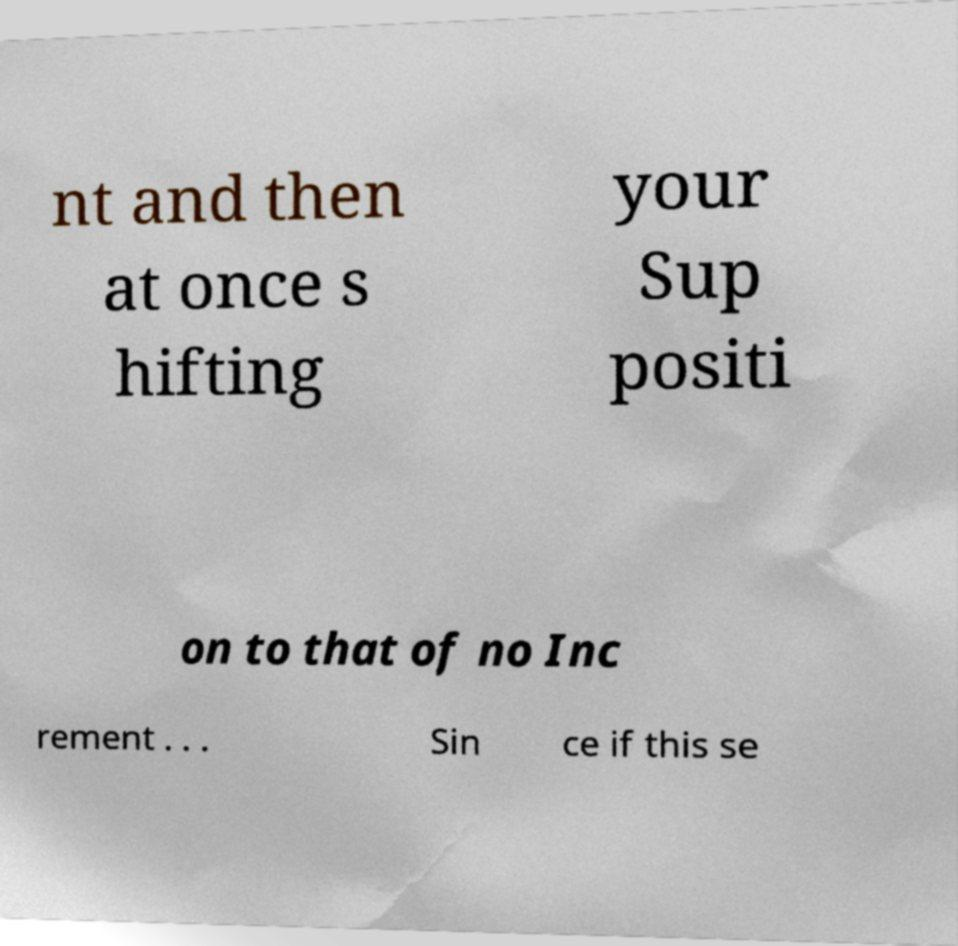Please read and relay the text visible in this image. What does it say? nt and then at once s hifting your Sup positi on to that of no Inc rement . . . Sin ce if this se 